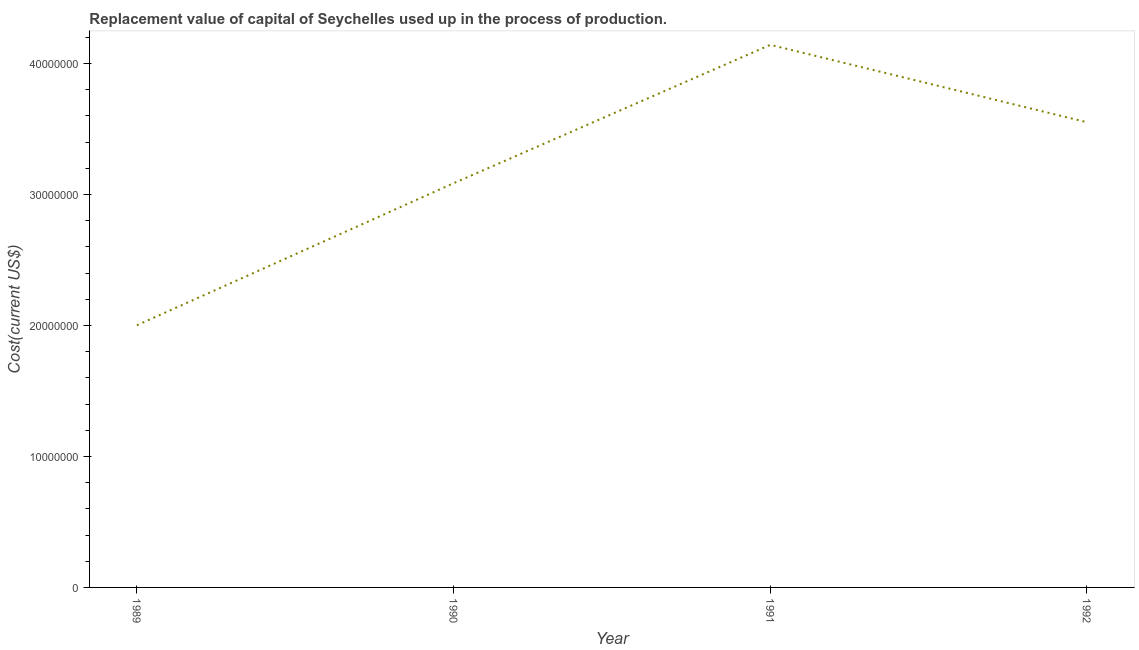What is the consumption of fixed capital in 1992?
Your answer should be very brief. 3.55e+07. Across all years, what is the maximum consumption of fixed capital?
Provide a succinct answer. 4.14e+07. Across all years, what is the minimum consumption of fixed capital?
Provide a succinct answer. 2.00e+07. In which year was the consumption of fixed capital maximum?
Make the answer very short. 1991. What is the sum of the consumption of fixed capital?
Offer a terse response. 1.28e+08. What is the difference between the consumption of fixed capital in 1989 and 1991?
Ensure brevity in your answer.  -2.14e+07. What is the average consumption of fixed capital per year?
Give a very brief answer. 3.20e+07. What is the median consumption of fixed capital?
Provide a succinct answer. 3.32e+07. What is the ratio of the consumption of fixed capital in 1990 to that in 1991?
Keep it short and to the point. 0.75. Is the difference between the consumption of fixed capital in 1990 and 1991 greater than the difference between any two years?
Your response must be concise. No. What is the difference between the highest and the second highest consumption of fixed capital?
Provide a short and direct response. 5.91e+06. Is the sum of the consumption of fixed capital in 1990 and 1992 greater than the maximum consumption of fixed capital across all years?
Provide a succinct answer. Yes. What is the difference between the highest and the lowest consumption of fixed capital?
Your answer should be very brief. 2.14e+07. Does the consumption of fixed capital monotonically increase over the years?
Make the answer very short. No. How many lines are there?
Offer a very short reply. 1. How many years are there in the graph?
Make the answer very short. 4. What is the title of the graph?
Offer a terse response. Replacement value of capital of Seychelles used up in the process of production. What is the label or title of the Y-axis?
Your answer should be compact. Cost(current US$). What is the Cost(current US$) in 1989?
Give a very brief answer. 2.00e+07. What is the Cost(current US$) of 1990?
Your answer should be very brief. 3.09e+07. What is the Cost(current US$) in 1991?
Offer a terse response. 4.14e+07. What is the Cost(current US$) of 1992?
Your answer should be very brief. 3.55e+07. What is the difference between the Cost(current US$) in 1989 and 1990?
Make the answer very short. -1.08e+07. What is the difference between the Cost(current US$) in 1989 and 1991?
Give a very brief answer. -2.14e+07. What is the difference between the Cost(current US$) in 1989 and 1992?
Keep it short and to the point. -1.55e+07. What is the difference between the Cost(current US$) in 1990 and 1991?
Offer a terse response. -1.06e+07. What is the difference between the Cost(current US$) in 1990 and 1992?
Provide a short and direct response. -4.66e+06. What is the difference between the Cost(current US$) in 1991 and 1992?
Your response must be concise. 5.91e+06. What is the ratio of the Cost(current US$) in 1989 to that in 1990?
Your answer should be very brief. 0.65. What is the ratio of the Cost(current US$) in 1989 to that in 1991?
Ensure brevity in your answer.  0.48. What is the ratio of the Cost(current US$) in 1989 to that in 1992?
Ensure brevity in your answer.  0.56. What is the ratio of the Cost(current US$) in 1990 to that in 1991?
Provide a short and direct response. 0.74. What is the ratio of the Cost(current US$) in 1990 to that in 1992?
Provide a succinct answer. 0.87. What is the ratio of the Cost(current US$) in 1991 to that in 1992?
Provide a succinct answer. 1.17. 